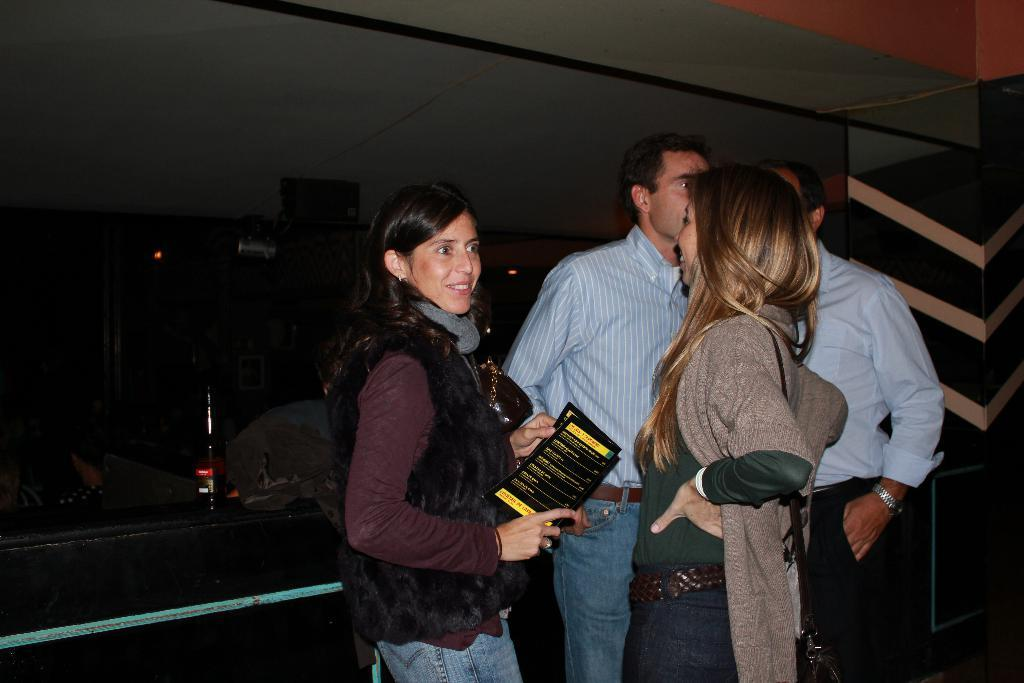How many people are in the image? There are people standing in the image. What is one person holding in their hand? One person is holding a paper in their hand. What can be observed about the background of the image? The background of the image is dark. What other object is visible in the image? There is a bottle visible in the image. What type of flesh can be seen in the image? There is no flesh present in the image. How is the paste being used in the image? There is no paste present in the image. 